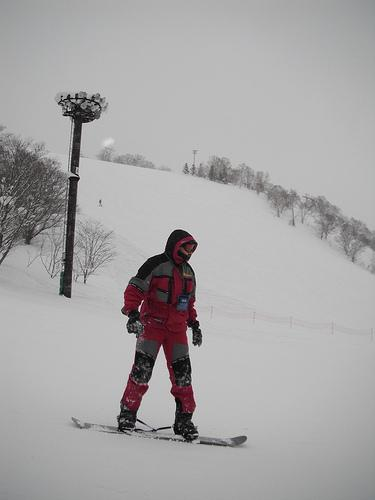Analyze the image sentiment—does it convey a sense of fun, danger, calmness, or something else? The image conveys a sense of excitement and adventure. What is the number of patches of white snow mentioned in the image? 9 How many instances of cut up pieces of meat on a plate are mentioned in the image? There are no cut up pieces of meat on a plate mentioned in the image. Mention the type of clothing the man is wearing. The man is wearing a red and black suit, a coat, protective goggles, black gloves, and black boots. What is the primary activity depicted in this image? A man is snowboarding in a snowy field. In a narrative form, provide a description of this wintry scene. A man dressed in a red and black suit, coat, protective goggles, black gloves, and black boots is snowboarding amidst a field covered with patches of snow. Surrounding him are small trees and a tower on ice with a gray sky in the background. Examine the head of the man for specific features or accessories. The man is wearing protective goggles and has his face covered with cloth. Observe the igloo-like structure found in the top right corner of the image, it looks like it's built with snow bricks. No, it's not mentioned in the image. Pay attention to the snowman on the right edge of the image, with a carrot for a nose and a black hat on its head. There is no snowman described in the provided object information. The instruction uses a combination of a request and a declarative sentence to encourage viewers to focus their attention on a nonexistent object while also providing unnecessary details that lead the viewer to believe it exists. 